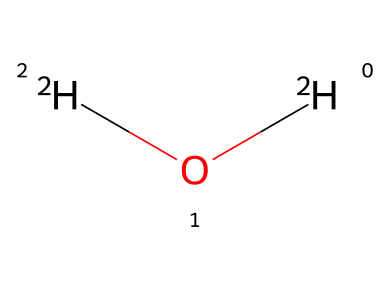What is the name of this chemical? The provided SMILES representation indicates the chemical consists of two hydrogen atoms (isotopes) and one oxygen atom, which is known as deuterium oxide or heavy water.
Answer: deuterium oxide How many hydrogen atoms are present? In the SMILES representation, there are two [2H] atoms, representing two deuterium atoms, and one oxygen atom. Therefore, there are two hydrogen atoms.
Answer: two What is the significance of the isotope in this chemical? The presence of the isotope deuterium (2H) instead of regular hydrogen (1H) gives heavy water unique properties, such as being a neutron moderator in nuclear reactors, which is significant in nuclear chemistry.
Answer: neutron moderator What is the total number of atoms in the chemical? The SMILES indicates there are two deuterium atoms and one oxygen atom, so the total number of atoms is three.
Answer: three What type of bonds connect the atoms in deuterium oxide? In deuterium oxide, the bonds connecting the deuterium atoms to the oxygen atom are covalent bonds, which occur due to the sharing of electrons.
Answer: covalent bonds Why is deuterium oxide used in nuclear reactors? Deuterium oxide is used in nuclear reactors primarily because of its ability to slow down neutrons effectively, making the nuclear fission process more efficient without absorbing neutrons, thus enabling better chain reactions.
Answer: slows down neutrons What is the density comparison between deuterium oxide and regular water? Deuterium oxide has a higher density than regular water due to the presence of deuterium isotopes, which increases the mass of the molecules.
Answer: higher density 